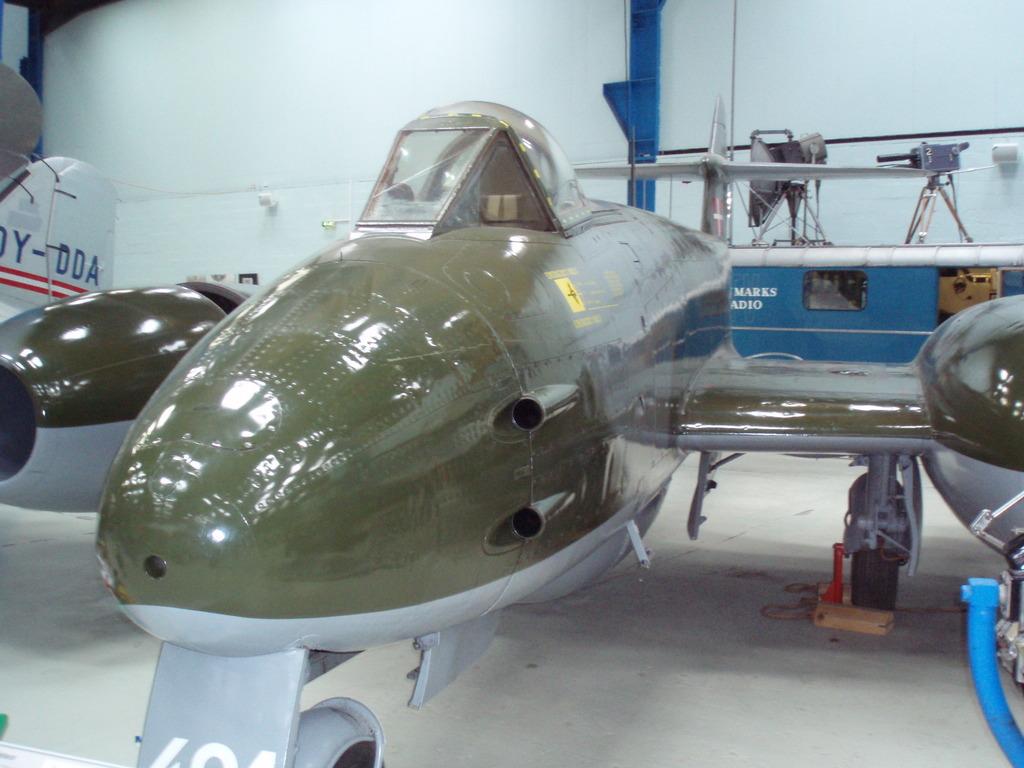What's the letter on the place to the far left?
Keep it short and to the point. Y. 